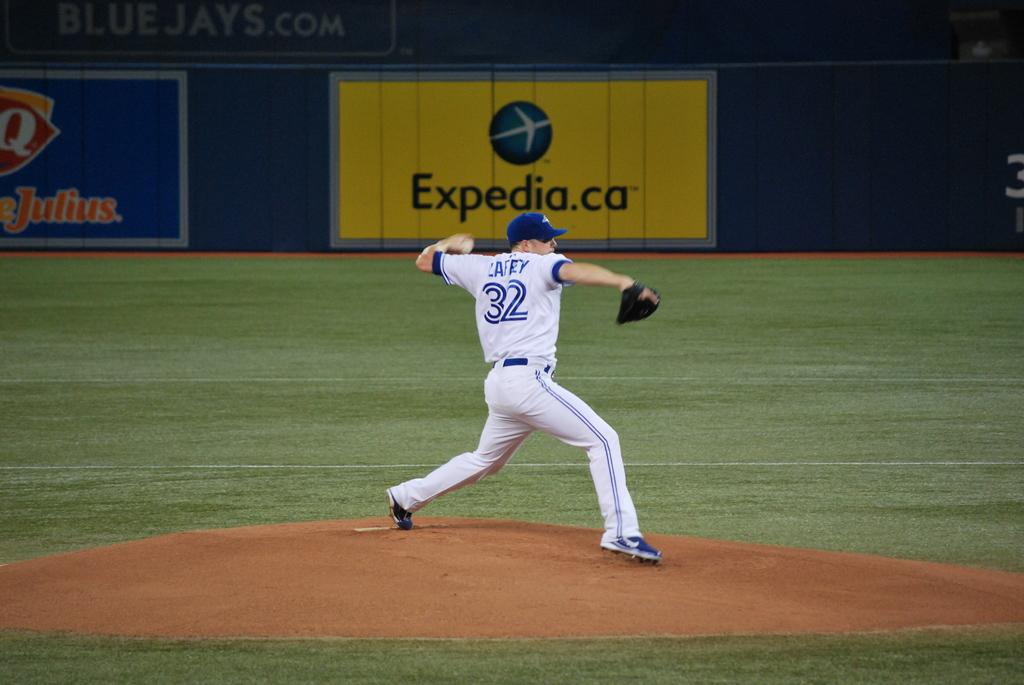<image>
Present a compact description of the photo's key features. One of the sponsors for the baseball stadium in Toronto is Expedia.ca. 